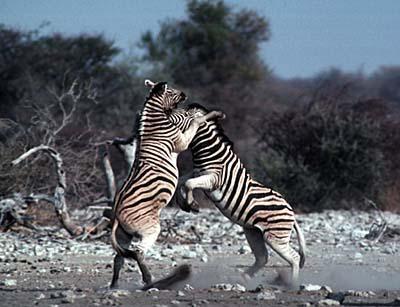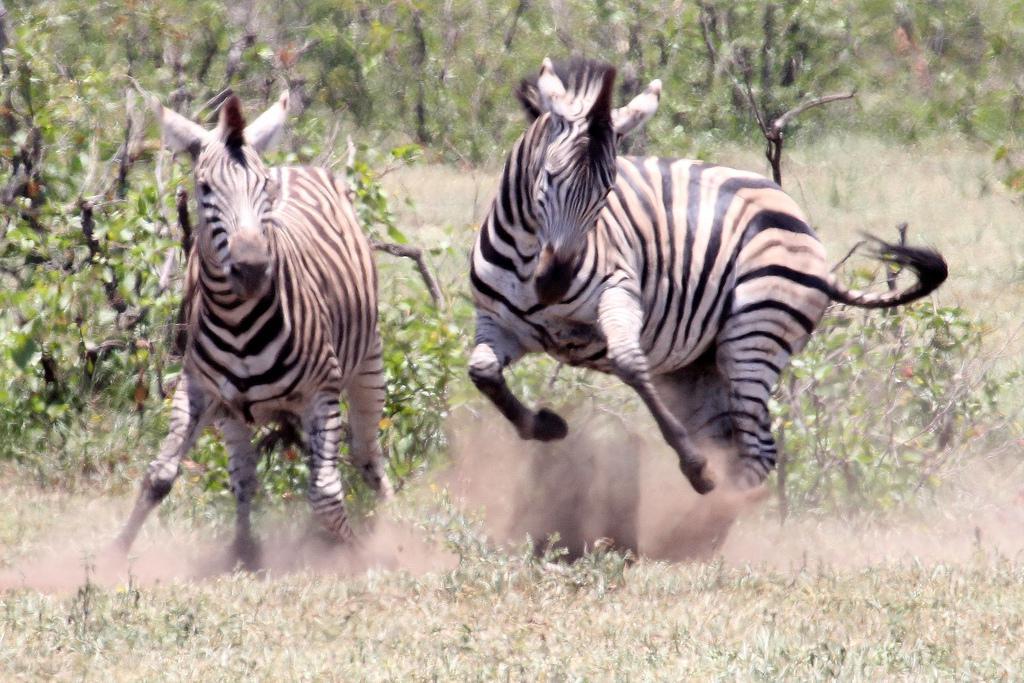The first image is the image on the left, the second image is the image on the right. For the images displayed, is the sentence "Fewer than 3 Zebras total." factually correct? Answer yes or no. No. The first image is the image on the left, the second image is the image on the right. Considering the images on both sides, is "One image shows two animals with their necks crossed and overlapping in a non-confrontational pose." valid? Answer yes or no. No. 